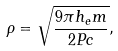Convert formula to latex. <formula><loc_0><loc_0><loc_500><loc_500>\rho = \sqrt { \frac { 9 \pi h _ { e } m } { 2 P c } } ,</formula> 